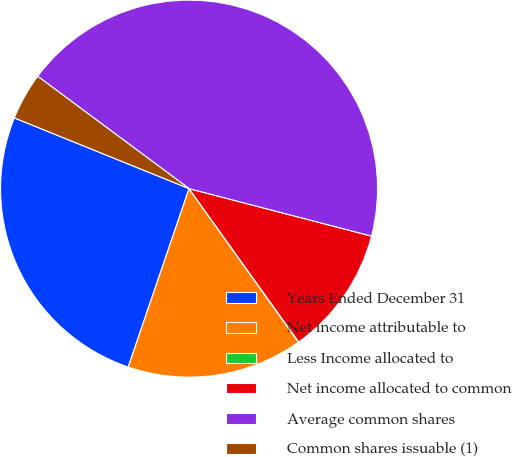Convert chart to OTSL. <chart><loc_0><loc_0><loc_500><loc_500><pie_chart><fcel>Years Ended December 31<fcel>Net income attributable to<fcel>Less Income allocated to<fcel>Net income allocated to common<fcel>Average common shares<fcel>Common shares issuable (1)<nl><fcel>25.89%<fcel>15.08%<fcel>0.03%<fcel>11.07%<fcel>43.89%<fcel>4.04%<nl></chart> 